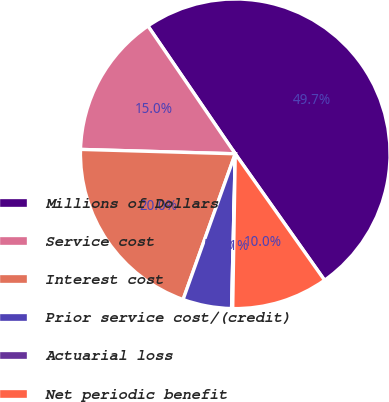<chart> <loc_0><loc_0><loc_500><loc_500><pie_chart><fcel>Millions of Dollars<fcel>Service cost<fcel>Interest cost<fcel>Prior service cost/(credit)<fcel>Actuarial loss<fcel>Net periodic benefit<nl><fcel>49.75%<fcel>15.01%<fcel>19.98%<fcel>5.09%<fcel>0.12%<fcel>10.05%<nl></chart> 